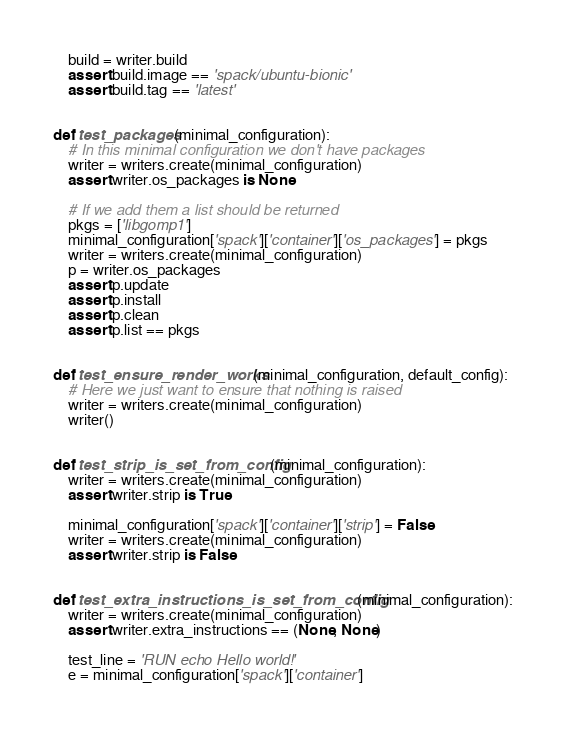<code> <loc_0><loc_0><loc_500><loc_500><_Python_>    build = writer.build
    assert build.image == 'spack/ubuntu-bionic'
    assert build.tag == 'latest'


def test_packages(minimal_configuration):
    # In this minimal configuration we don't have packages
    writer = writers.create(minimal_configuration)
    assert writer.os_packages is None

    # If we add them a list should be returned
    pkgs = ['libgomp1']
    minimal_configuration['spack']['container']['os_packages'] = pkgs
    writer = writers.create(minimal_configuration)
    p = writer.os_packages
    assert p.update
    assert p.install
    assert p.clean
    assert p.list == pkgs


def test_ensure_render_works(minimal_configuration, default_config):
    # Here we just want to ensure that nothing is raised
    writer = writers.create(minimal_configuration)
    writer()


def test_strip_is_set_from_config(minimal_configuration):
    writer = writers.create(minimal_configuration)
    assert writer.strip is True

    minimal_configuration['spack']['container']['strip'] = False
    writer = writers.create(minimal_configuration)
    assert writer.strip is False


def test_extra_instructions_is_set_from_config(minimal_configuration):
    writer = writers.create(minimal_configuration)
    assert writer.extra_instructions == (None, None)

    test_line = 'RUN echo Hello world!'
    e = minimal_configuration['spack']['container']</code> 